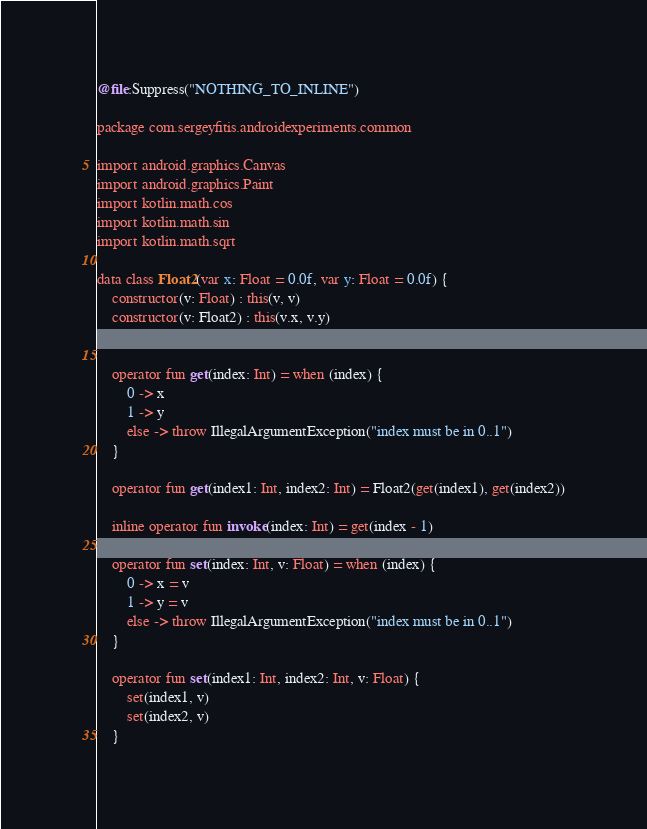Convert code to text. <code><loc_0><loc_0><loc_500><loc_500><_Kotlin_>@file:Suppress("NOTHING_TO_INLINE")

package com.sergeyfitis.androidexperiments.common

import android.graphics.Canvas
import android.graphics.Paint
import kotlin.math.cos
import kotlin.math.sin
import kotlin.math.sqrt

data class Float2(var x: Float = 0.0f, var y: Float = 0.0f) {
    constructor(v: Float) : this(v, v)
    constructor(v: Float2) : this(v.x, v.y)


    operator fun get(index: Int) = when (index) {
        0 -> x
        1 -> y
        else -> throw IllegalArgumentException("index must be in 0..1")
    }

    operator fun get(index1: Int, index2: Int) = Float2(get(index1), get(index2))

    inline operator fun invoke(index: Int) = get(index - 1)

    operator fun set(index: Int, v: Float) = when (index) {
        0 -> x = v
        1 -> y = v
        else -> throw IllegalArgumentException("index must be in 0..1")
    }

    operator fun set(index1: Int, index2: Int, v: Float) {
        set(index1, v)
        set(index2, v)
    }</code> 